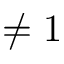<formula> <loc_0><loc_0><loc_500><loc_500>\neq 1</formula> 